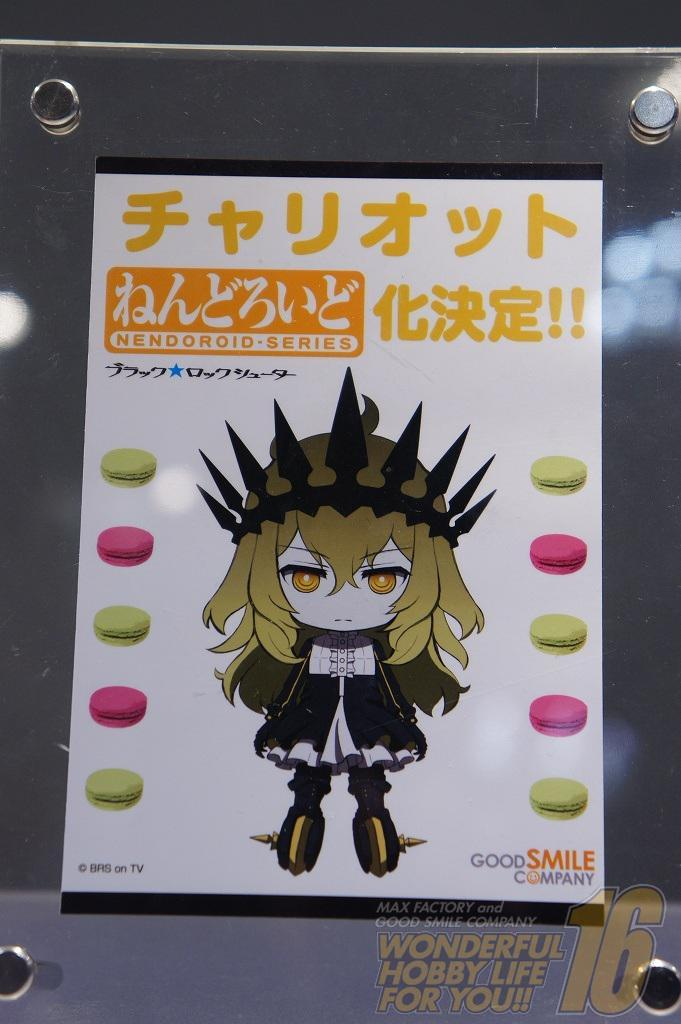What is located in the foreground of the picture? There is a poster in the foreground of the picture. How is the poster attached to the glass? The poster is stuck on a glass. What feature can be observed at the bottom of the glass? There are holes at the bottom of the glass. What can be seen at the top of the glass? There are bolts and a hole at the top of the glass. What is the value of the trip mentioned in the image? There is no mention of a trip in the image; the facts provided focus on a poster, a glass, and its features. 